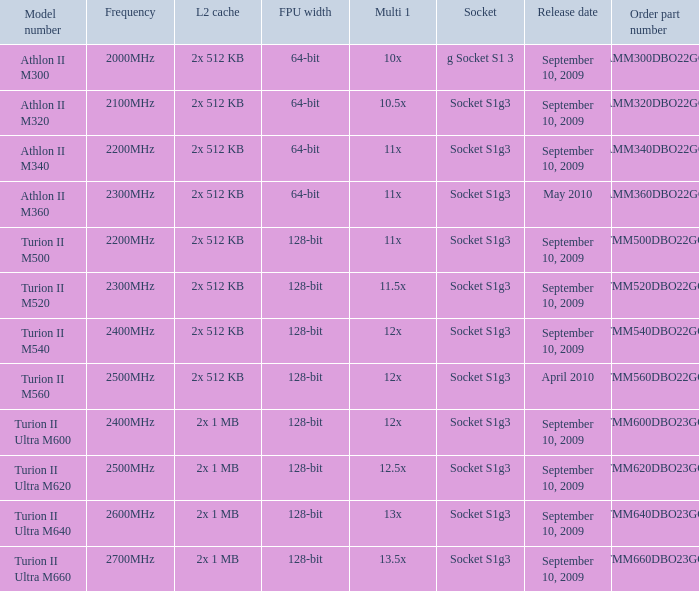What is the tmm500dbo22gq order part number's frequency? 2200MHz. 